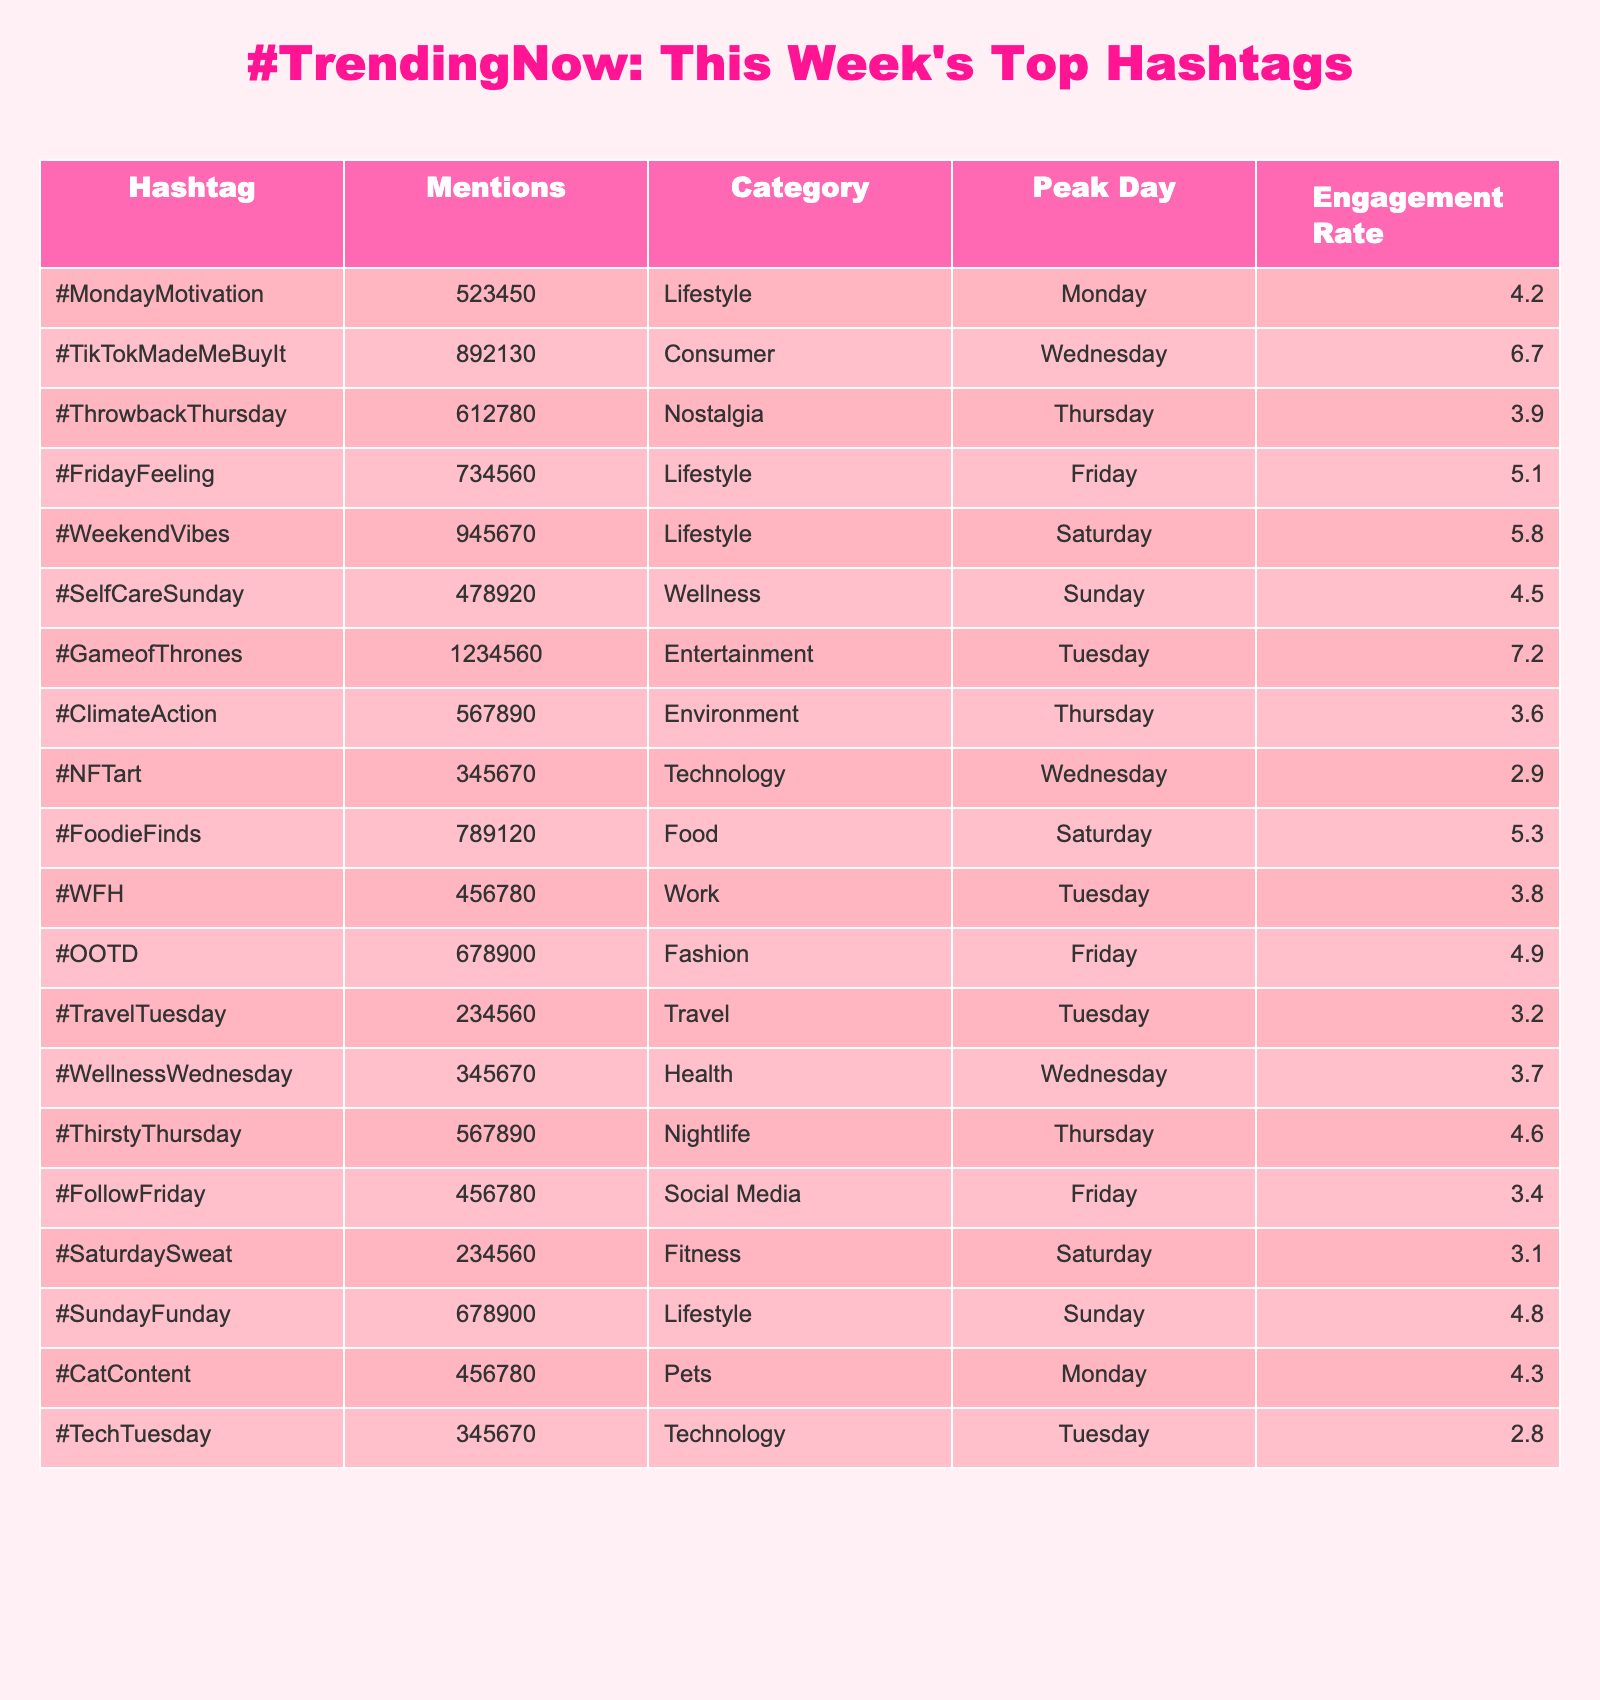What is the hashtag with the highest mentions? Looking at the table, the hashtag with the highest mentions is #GameofThrones, with a total of 1,234,560 mentions.
Answer: #GameofThrones Which category does the hashtag #FoodieFinds belong to? By scanning the table, we see that #FoodieFinds falls under the category of Food.
Answer: Food What is the engagement rate of the hashtag #WeekendVibes? The table shows that #WeekendVibes has an engagement rate of 5.8%.
Answer: 5.8% How many mentions do the hashtags in the Lifestyle category have in total? The hashtags in the Lifestyle category are #MondayMotivation, #FridayFeeling, #WeekendVibes, and #SundayFunday, which have 523,450 + 734,560 + 945,670 + 678,900 = 2,982,580 mentions in total.
Answer: 2,982,580 Is the engagement rate of #ThrowbackThursday higher than that of #ClimateAction? The engagement rate for #ThrowbackThursday is 3.9% while for #ClimateAction it is 3.6%. Since 3.9% is greater, the statement is true.
Answer: Yes What are the top three hashtags by engagement rate? To find the top three, we look for the highest engagement rates: #GameofThrones (7.2%), #TikTokMadeMeBuyIt (6.7%), and #WeekendVibes (5.8%).
Answer: #GameofThrones, #TikTokMadeMeBuyIt, #WeekendVibes Which day had the highest engagement for hashtags? The hashtags with peak days are Monday (#MondayMotivation), Wednesday (#TikTokMadeMeBuyIt), Thursday (#ThrowbackThursday), etc. The highest engagement is 7.2% on Tuesday for #GameofThrones.
Answer: Tuesday How does the engagement rate of #WFH compare to that of #SelfCareSunday? The engagement rate for #WFH is 3.8% and for #SelfCareSunday it is 4.5%. Since 4.5% is greater, #SelfCareSunday has a higher rate.
Answer: #SelfCareSunday is higher What percentage of the total mentions do the hashtags in the Technology category represent? The Technology category has two hashtags (#NFTart and #TechTuesday) with mentions of 345,670 + 345,670 = 691,340. The total mentions are 5,927,875. So, (691,340 / 5,927,875) * 100 ≈ 11.7%.
Answer: 11.7% Which category has the least engagement rate? Looking at the engagement rates, #NFTart has the lowest engagement rate of 2.9%, which is under Technology category.
Answer: Technology 